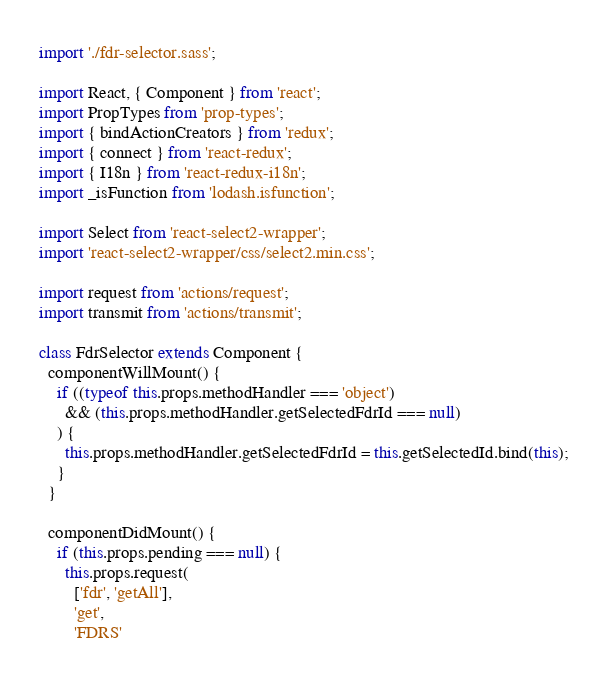<code> <loc_0><loc_0><loc_500><loc_500><_JavaScript_>import './fdr-selector.sass';

import React, { Component } from 'react';
import PropTypes from 'prop-types';
import { bindActionCreators } from 'redux';
import { connect } from 'react-redux';
import { I18n } from 'react-redux-i18n';
import _isFunction from 'lodash.isfunction';

import Select from 'react-select2-wrapper';
import 'react-select2-wrapper/css/select2.min.css';

import request from 'actions/request';
import transmit from 'actions/transmit';

class FdrSelector extends Component {
  componentWillMount() {
    if ((typeof this.props.methodHandler === 'object')
      && (this.props.methodHandler.getSelectedFdrId === null)
    ) {
      this.props.methodHandler.getSelectedFdrId = this.getSelectedId.bind(this);
    }
  }

  componentDidMount() {
    if (this.props.pending === null) {
      this.props.request(
        ['fdr', 'getAll'],
        'get',
        'FDRS'</code> 